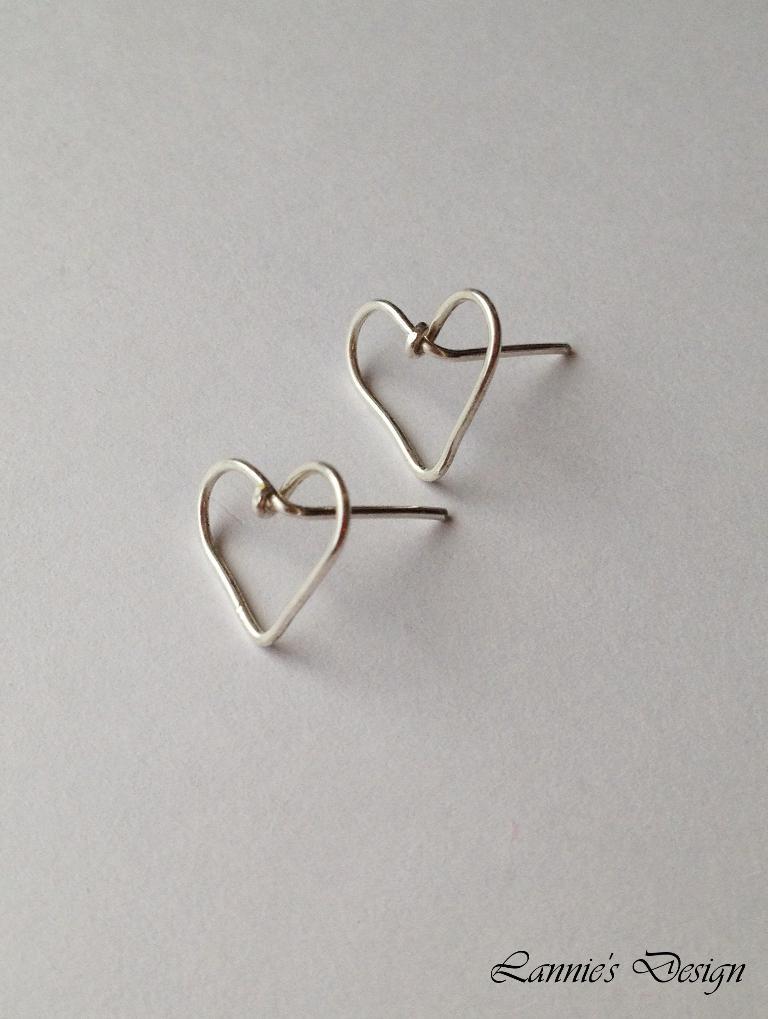How would you summarize this image in a sentence or two? In the picture I can see some objects on a white color surface. On the bottom right side of the image I can see a watermark. 